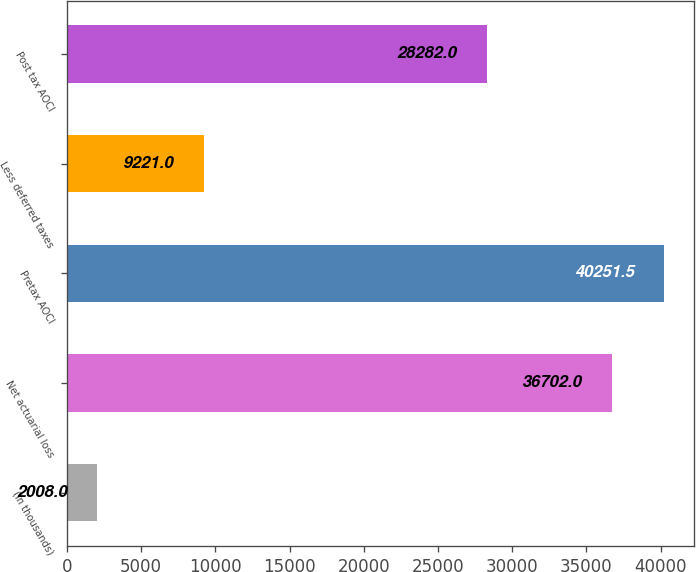Convert chart. <chart><loc_0><loc_0><loc_500><loc_500><bar_chart><fcel>(in thousands)<fcel>Net actuarial loss<fcel>Pretax AOCI<fcel>Less deferred taxes<fcel>Post tax AOCI<nl><fcel>2008<fcel>36702<fcel>40251.5<fcel>9221<fcel>28282<nl></chart> 